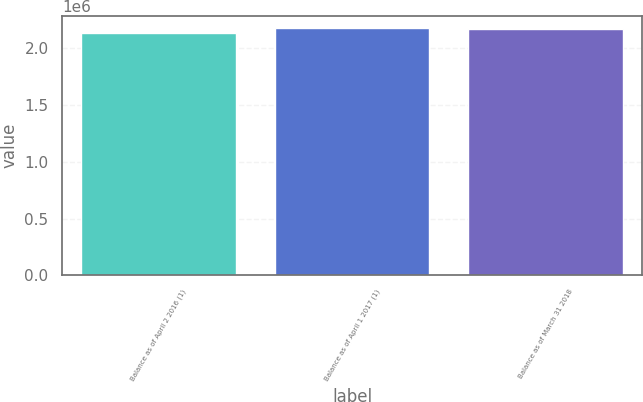Convert chart. <chart><loc_0><loc_0><loc_500><loc_500><bar_chart><fcel>Balance as of April 2 2016 (1)<fcel>Balance as of April 1 2017 (1)<fcel>Balance as of March 31 2018<nl><fcel>2.1357e+06<fcel>2.17771e+06<fcel>2.17389e+06<nl></chart> 